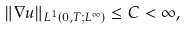Convert formula to latex. <formula><loc_0><loc_0><loc_500><loc_500>\| \nabla u \| _ { L ^ { 1 } ( 0 , T ; L ^ { \infty } ) } \leq C < \infty ,</formula> 